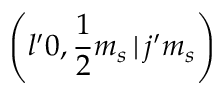Convert formula to latex. <formula><loc_0><loc_0><loc_500><loc_500>\left ( l ^ { \prime } 0 , \frac { 1 } { 2 } m _ { s } \, | \, j ^ { \prime } m _ { s } \right )</formula> 